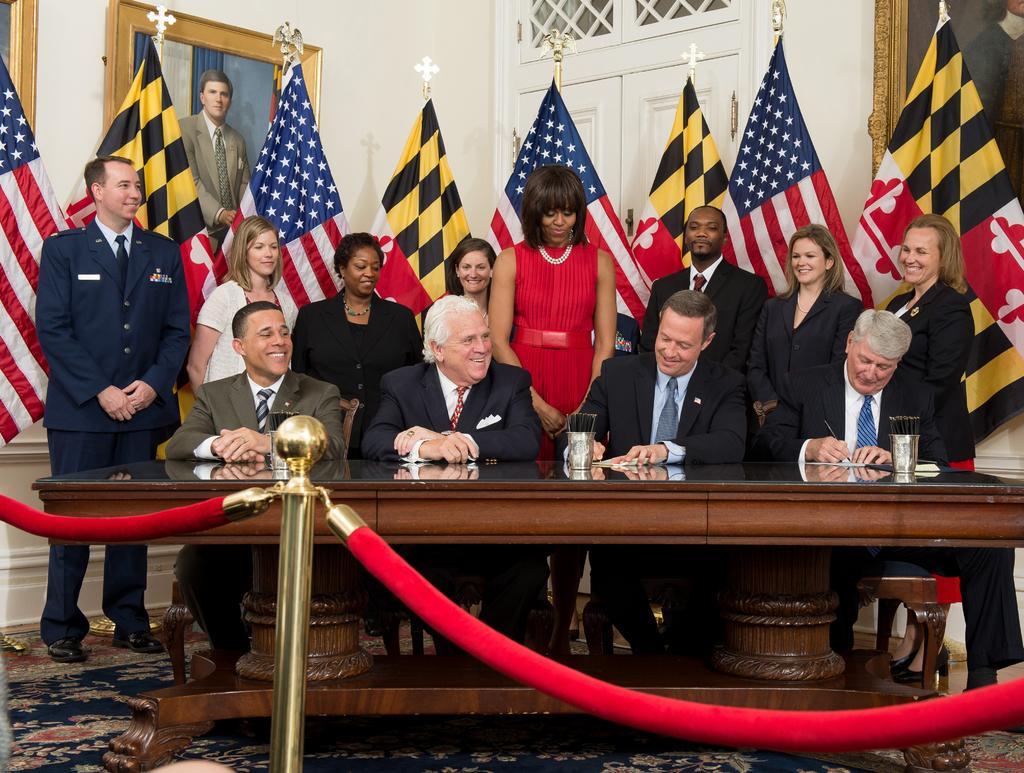Could you give a brief overview of what you see in this image? In this picture we can see four persons are sitting and some people are standing, there is a table in the middle, we can see papers and glasses on the table, two men on the right side are writing something, in the background there are some flags, a door and a wall, there is a photo frame on the wall, there is a queue manager in the front. 